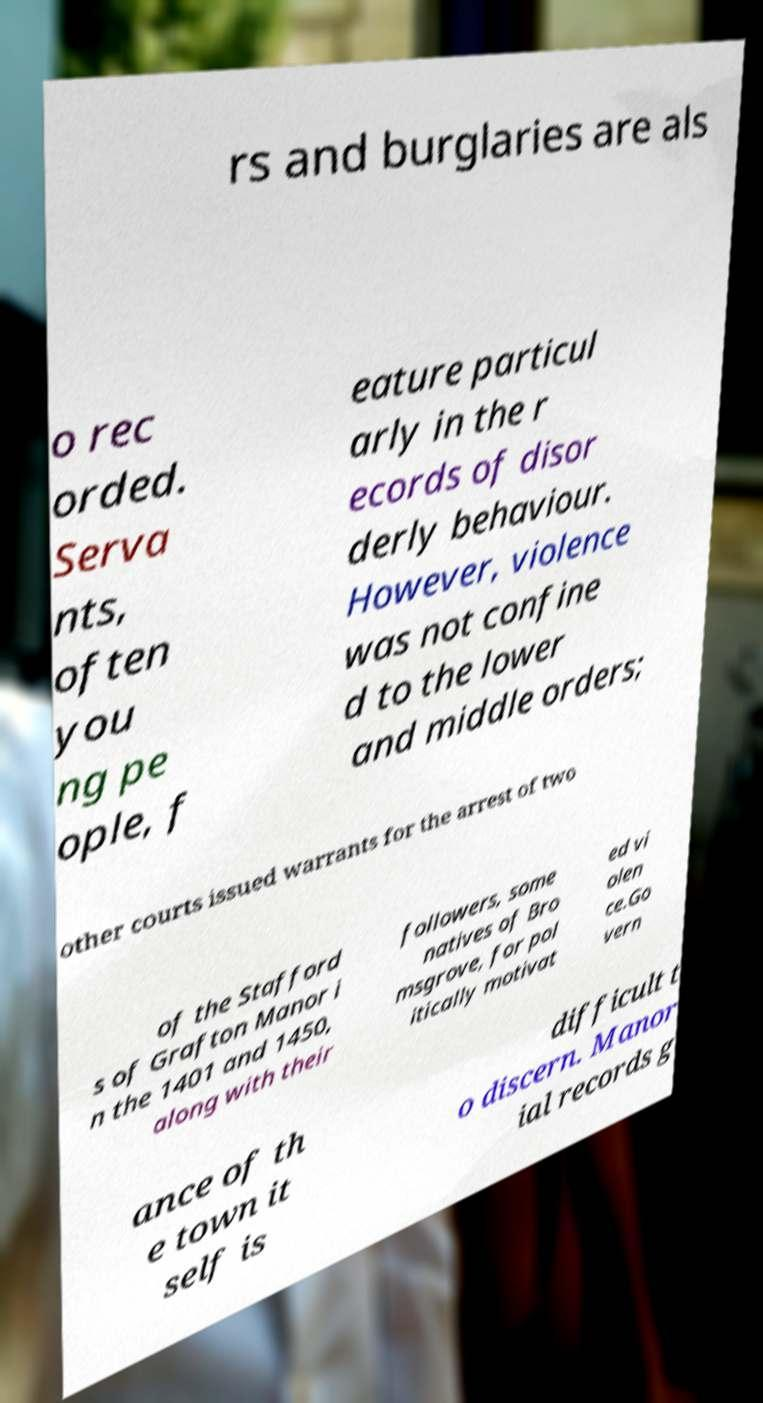Please identify and transcribe the text found in this image. rs and burglaries are als o rec orded. Serva nts, often you ng pe ople, f eature particul arly in the r ecords of disor derly behaviour. However, violence was not confine d to the lower and middle orders; other courts issued warrants for the arrest of two of the Stafford s of Grafton Manor i n the 1401 and 1450, along with their followers, some natives of Bro msgrove, for pol itically motivat ed vi olen ce.Go vern ance of th e town it self is difficult t o discern. Manor ial records g 